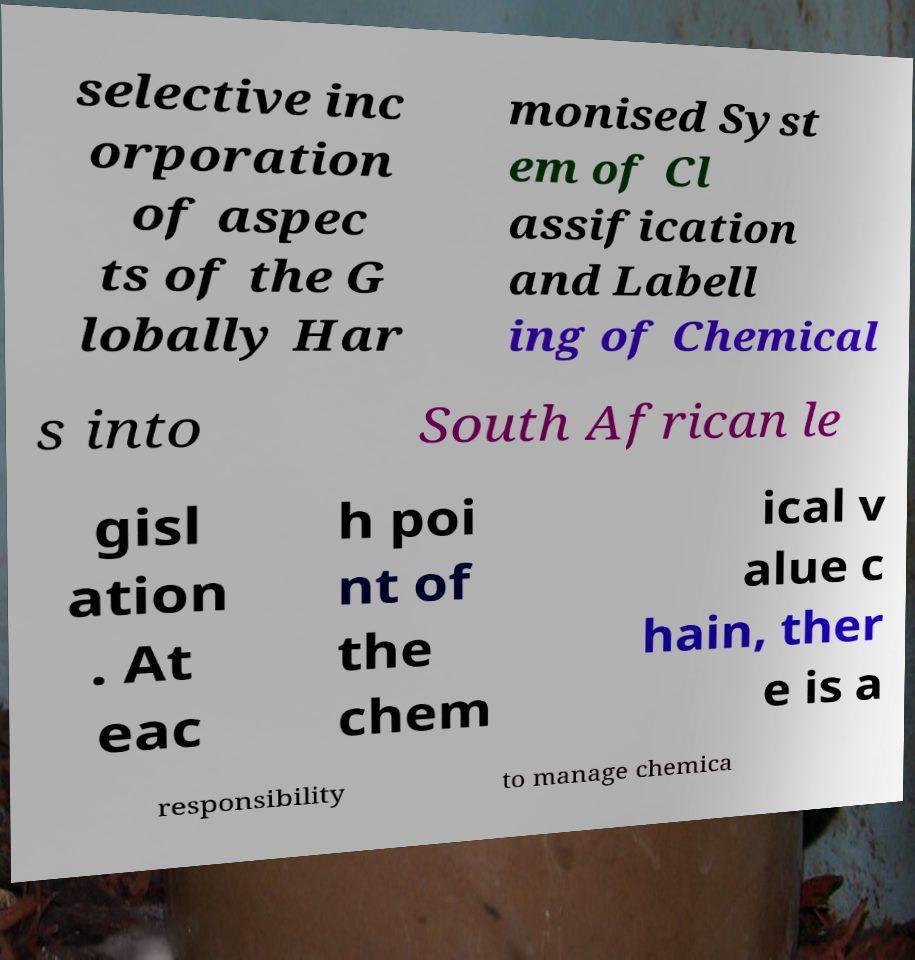Please identify and transcribe the text found in this image. selective inc orporation of aspec ts of the G lobally Har monised Syst em of Cl assification and Labell ing of Chemical s into South African le gisl ation . At eac h poi nt of the chem ical v alue c hain, ther e is a responsibility to manage chemica 